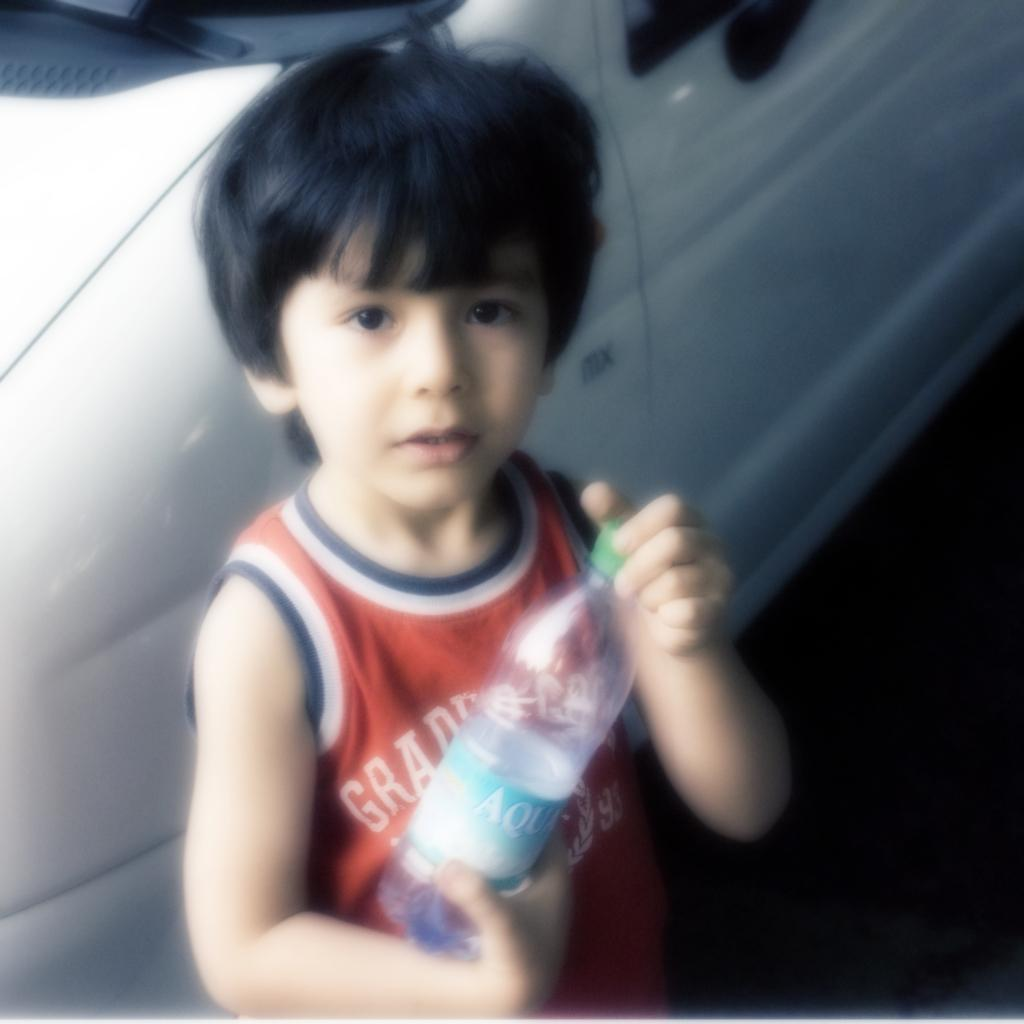What is the main subject of the image? The main subject of the image is a kid. What is the kid doing in the image? The kid is standing in the image. What object is the kid holding in his hand? The kid is holding a water bottle in his hand. What can be seen in the background of the image? There is a car visible behind the kid. What type of toothbrush is the kid using in the image? There is no toothbrush present in the image. How many girls are visible in the image? There are no girls visible in the image; the main subject is a kid. 